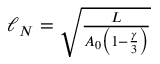<formula> <loc_0><loc_0><loc_500><loc_500>\begin{array} { r } { \ell _ { N } = \sqrt { \frac { L } { A _ { 0 } \left ( 1 - \frac { \gamma } { 3 } \right ) } } } \end{array}</formula> 